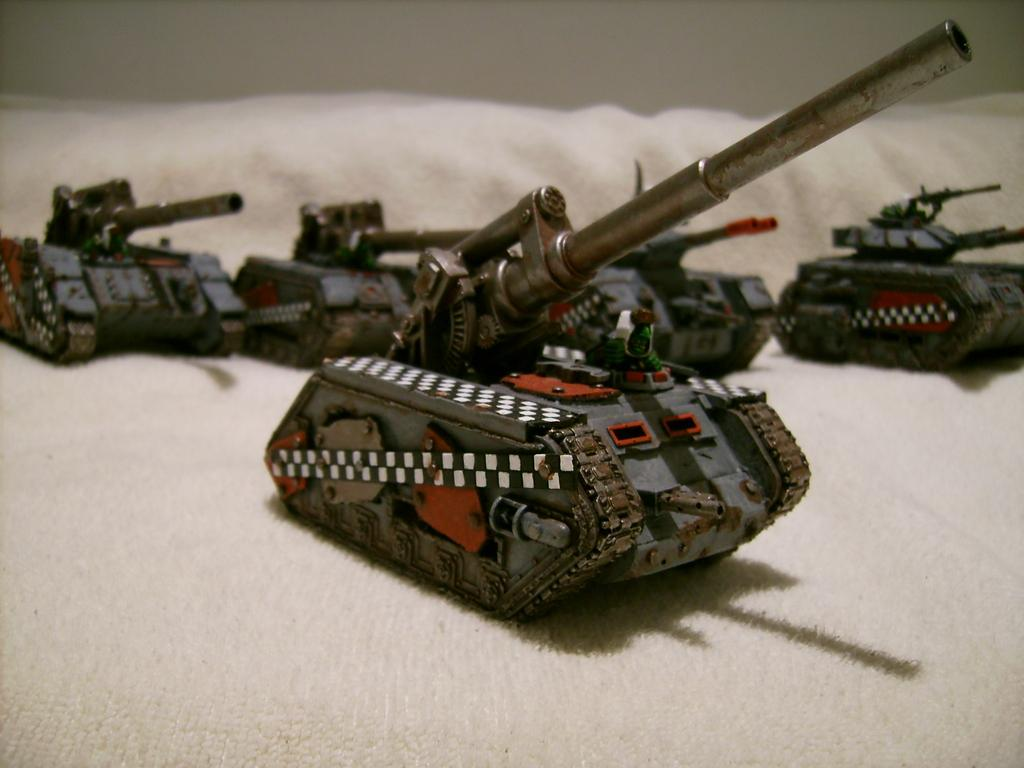What type of vehicles are present in the image? There are panzers in the image. What is the surface on which the panzers are placed? The panzers are placed on a white color cloth. What is the color of the background in the image? The background of the image is white in color. Can you see any salt being sprinkled on the road in the image? There is no salt or road present in the image; it features panzers placed on a white color cloth with a white background. 